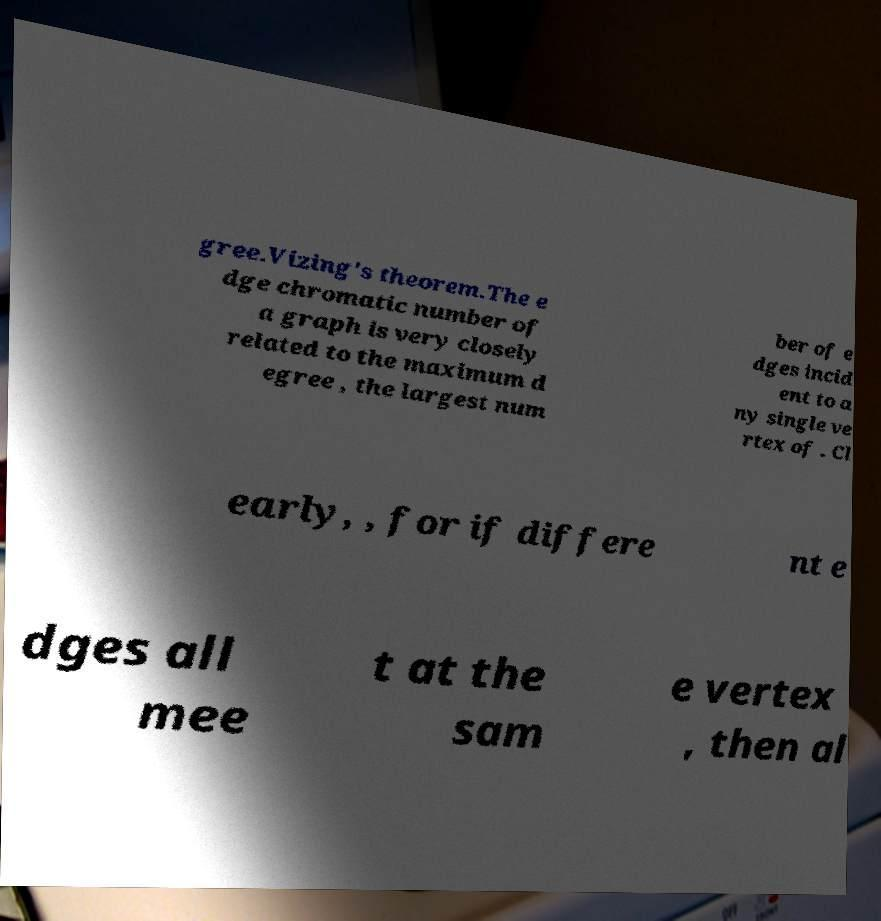For documentation purposes, I need the text within this image transcribed. Could you provide that? gree.Vizing's theorem.The e dge chromatic number of a graph is very closely related to the maximum d egree , the largest num ber of e dges incid ent to a ny single ve rtex of . Cl early, , for if differe nt e dges all mee t at the sam e vertex , then al 